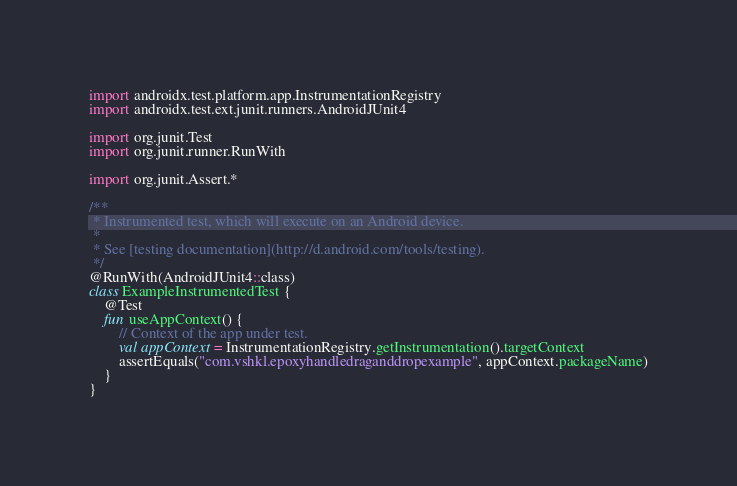<code> <loc_0><loc_0><loc_500><loc_500><_Kotlin_>
import androidx.test.platform.app.InstrumentationRegistry
import androidx.test.ext.junit.runners.AndroidJUnit4

import org.junit.Test
import org.junit.runner.RunWith

import org.junit.Assert.*

/**
 * Instrumented test, which will execute on an Android device.
 *
 * See [testing documentation](http://d.android.com/tools/testing).
 */
@RunWith(AndroidJUnit4::class)
class ExampleInstrumentedTest {
    @Test
    fun useAppContext() {
        // Context of the app under test.
        val appContext = InstrumentationRegistry.getInstrumentation().targetContext
        assertEquals("com.vshkl.epoxyhandledraganddropexample", appContext.packageName)
    }
}</code> 